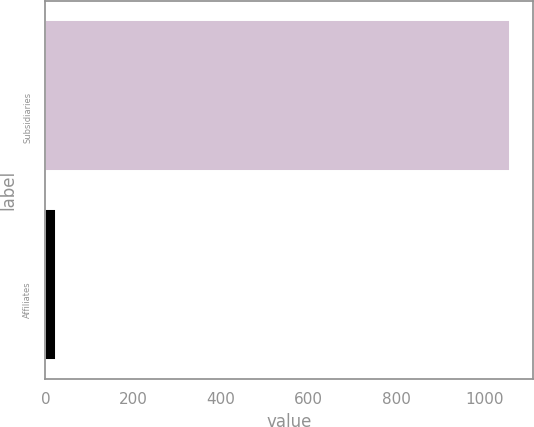<chart> <loc_0><loc_0><loc_500><loc_500><bar_chart><fcel>Subsidiaries<fcel>Affiliates<nl><fcel>1059<fcel>25<nl></chart> 